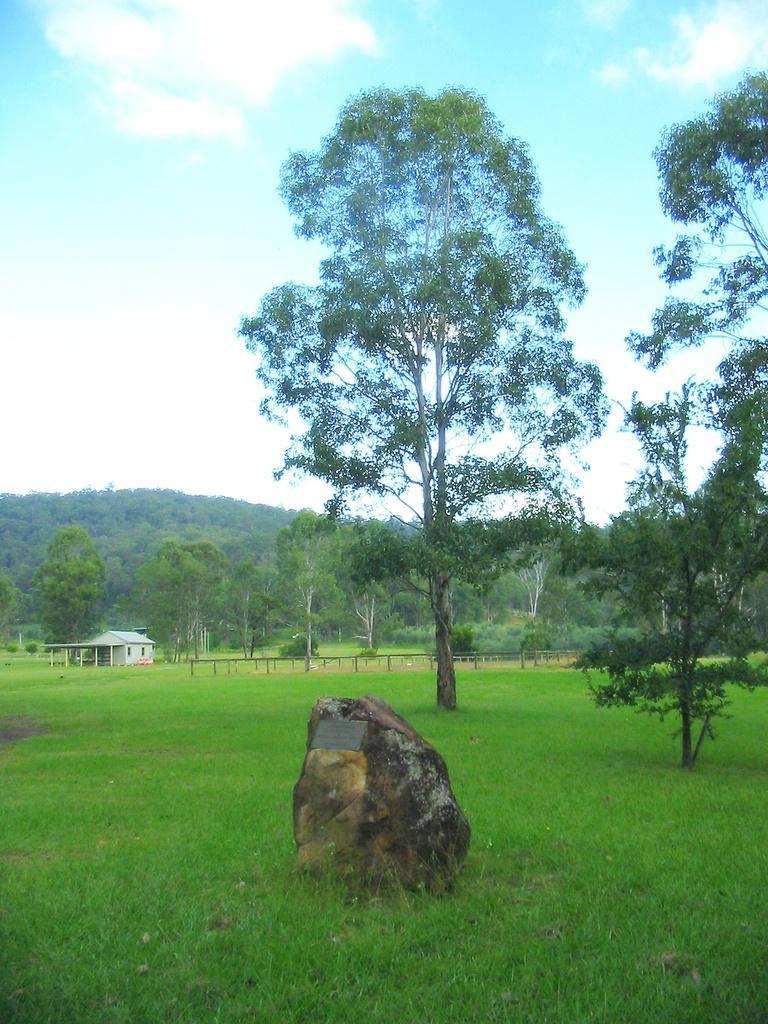Describe this image in one or two sentences. This image consists of a rock. At the bottom, there is green grass. In the background, there are many trees and plants. To the left, there is a small house. 